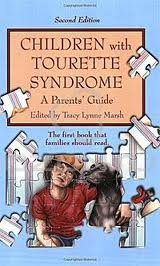Who wrote this book?
Answer the question using a single word or phrase. Tracy Lynne Marsh What is the title of this book? Children with Tourette Syndrome 2nd (second) edition Text Only What is the genre of this book? Health, Fitness & Dieting Is this a fitness book? Yes Is this a crafts or hobbies related book? No What is the version of this book? 2 